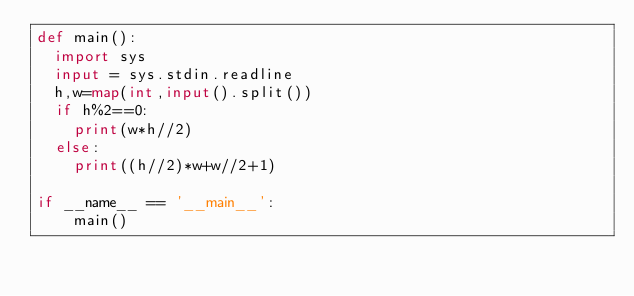Convert code to text. <code><loc_0><loc_0><loc_500><loc_500><_Python_>def main():
  import sys
  input = sys.stdin.readline
  h,w=map(int,input().split())
  if h%2==0:
    print(w*h//2)
  else:
    print((h//2)*w+w//2+1)
  
if __name__ == '__main__':
    main()
</code> 